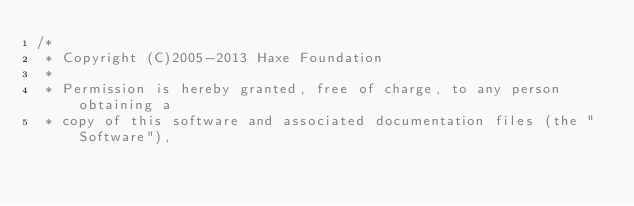Convert code to text. <code><loc_0><loc_0><loc_500><loc_500><_Haxe_>/*
 * Copyright (C)2005-2013 Haxe Foundation
 *
 * Permission is hereby granted, free of charge, to any person obtaining a
 * copy of this software and associated documentation files (the "Software"),</code> 